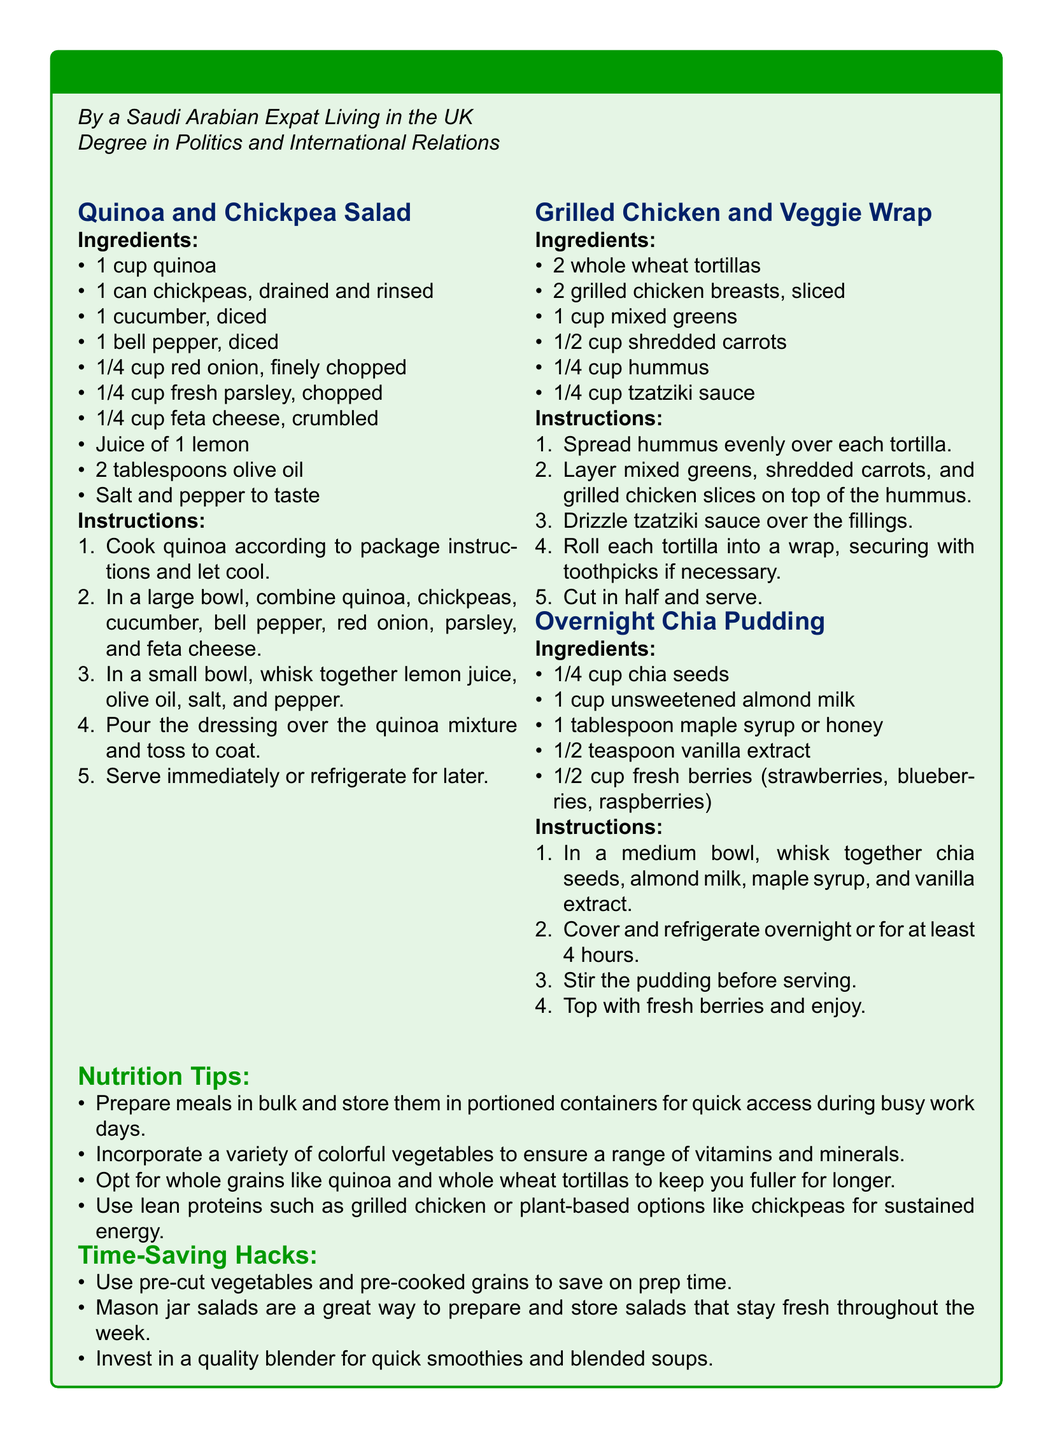What is the first recipe listed? The first recipe in the document is for Quinoa and Chickpea Salad.
Answer: Quinoa and Chickpea Salad How many tortillas are needed for the Grilled Chicken and Veggie Wrap? The recipe for the Grilled Chicken and Veggie Wrap requires 2 whole wheat tortillas.
Answer: 2 What type of milk is used in the Overnight Chia Pudding recipe? The Overnight Chia Pudding recipe uses unsweetened almond milk.
Answer: unsweetened almond milk What is the main protein source in the Quinoa and Chickpea Salad? The main protein source in the Quinoa and Chickpea Salad is chickpeas.
Answer: chickpeas What should be done with the chia pudding before serving? The chia pudding should be stirred before serving.
Answer: Stir the pudding List one nutrition tip mentioned in the document. One nutrition tip mentioned is to prepare meals in bulk and store them in portioned containers.
Answer: Prepare meals in bulk What is suggested to save on prep time? The document suggests using pre-cut vegetables and pre-cooked grains to save on prep time.
Answer: Use pre-cut vegetables How long should the chia pudding be refrigerated? The chia pudding should be refrigerated overnight or for at least 4 hours.
Answer: overnight or 4 hours What is the purpose of using mason jar salads? Mason jar salads are for preparing and storing salads that stay fresh throughout the week.
Answer: Stay fresh throughout the week 